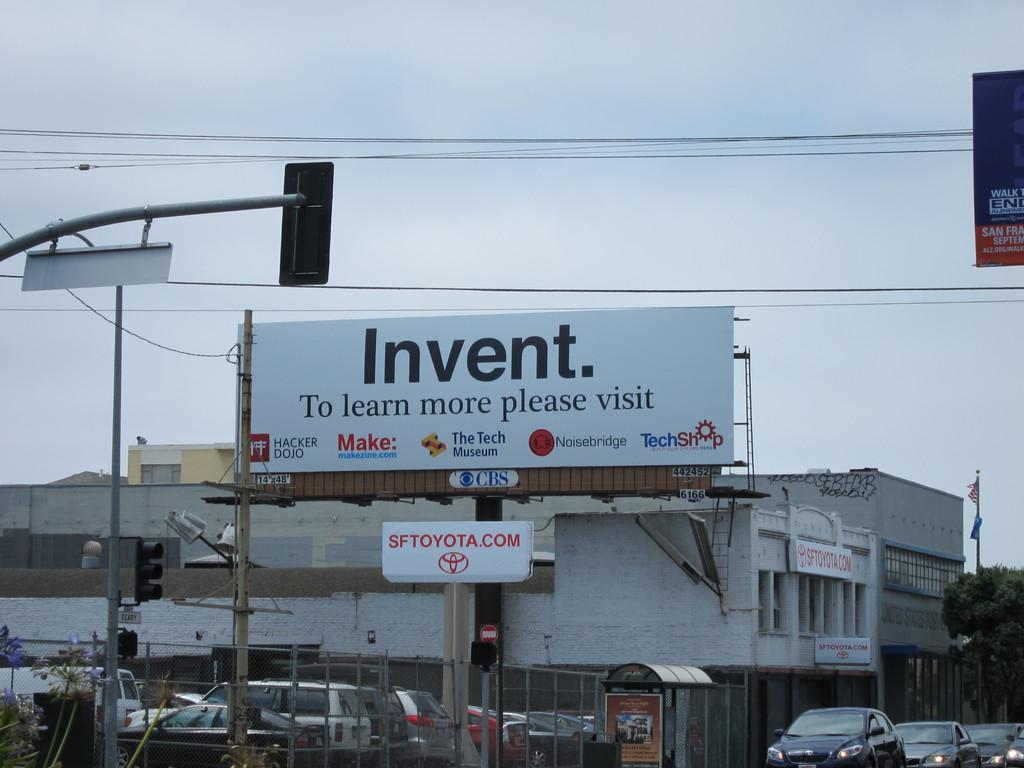<image>
Give a short and clear explanation of the subsequent image. A white billboard with text "Invent. To learn more please visit HACKER DOJO, Make: makenzie.com, The Tech Museum, Noisebridge, TechShop Build Your Dreams Here" in front of two white buildings. 